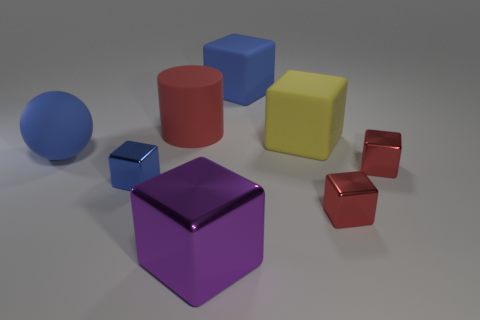Are there any other things that have the same shape as the red rubber thing?
Your answer should be very brief. No. Do the small blue object and the ball have the same material?
Provide a succinct answer. No. What is the size of the blue thing that is both behind the tiny blue metallic cube and to the left of the purple metal cube?
Give a very brief answer. Large. There is a red thing that is the same size as the blue matte block; what shape is it?
Offer a terse response. Cylinder. There is a small thing in front of the blue cube in front of the rubber block that is behind the yellow matte block; what is it made of?
Offer a very short reply. Metal. There is a blue object that is behind the big yellow rubber object; is its shape the same as the rubber object that is left of the big red matte thing?
Provide a short and direct response. No. What number of other objects are the same material as the large yellow thing?
Your answer should be compact. 3. Does the small object that is on the left side of the large blue rubber block have the same material as the big block behind the large red thing?
Your answer should be very brief. No. There is a yellow object that is made of the same material as the big ball; what is its shape?
Your answer should be compact. Cube. Are there any other things that have the same color as the large metal cube?
Your response must be concise. No. 